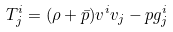<formula> <loc_0><loc_0><loc_500><loc_500>T ^ { i } _ { j } = ( \rho + \bar { p } ) v ^ { i } v _ { j } - p g ^ { i } _ { j }</formula> 